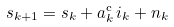<formula> <loc_0><loc_0><loc_500><loc_500>s _ { k + 1 } = s _ { k } + a ^ { \mathrm c } _ { k } \, i _ { k } + n _ { k }</formula> 